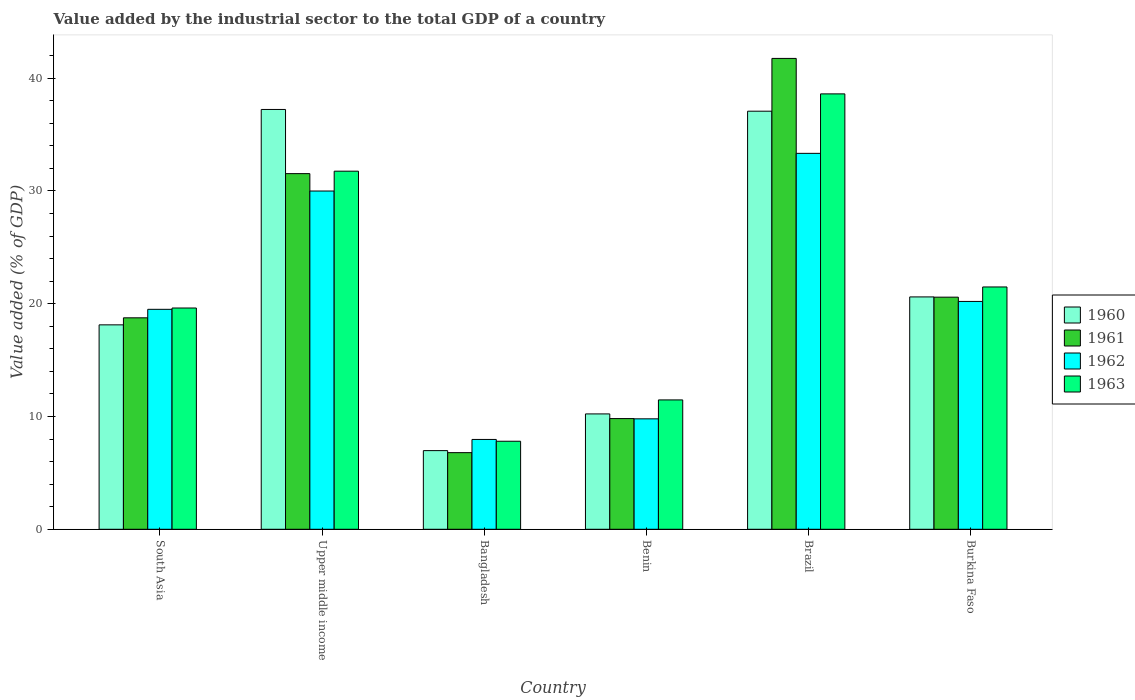How many different coloured bars are there?
Provide a short and direct response. 4. Are the number of bars per tick equal to the number of legend labels?
Keep it short and to the point. Yes. In how many cases, is the number of bars for a given country not equal to the number of legend labels?
Make the answer very short. 0. What is the value added by the industrial sector to the total GDP in 1963 in Bangladesh?
Make the answer very short. 7.8. Across all countries, what is the maximum value added by the industrial sector to the total GDP in 1963?
Keep it short and to the point. 38.6. Across all countries, what is the minimum value added by the industrial sector to the total GDP in 1961?
Give a very brief answer. 6.79. In which country was the value added by the industrial sector to the total GDP in 1960 maximum?
Offer a very short reply. Upper middle income. In which country was the value added by the industrial sector to the total GDP in 1962 minimum?
Your response must be concise. Bangladesh. What is the total value added by the industrial sector to the total GDP in 1961 in the graph?
Offer a very short reply. 129.21. What is the difference between the value added by the industrial sector to the total GDP in 1962 in Bangladesh and that in Upper middle income?
Keep it short and to the point. -22.02. What is the difference between the value added by the industrial sector to the total GDP in 1961 in Bangladesh and the value added by the industrial sector to the total GDP in 1963 in Burkina Faso?
Provide a short and direct response. -14.69. What is the average value added by the industrial sector to the total GDP in 1962 per country?
Offer a very short reply. 20.13. What is the difference between the value added by the industrial sector to the total GDP of/in 1961 and value added by the industrial sector to the total GDP of/in 1963 in Benin?
Ensure brevity in your answer.  -1.66. What is the ratio of the value added by the industrial sector to the total GDP in 1960 in Bangladesh to that in South Asia?
Provide a succinct answer. 0.38. What is the difference between the highest and the second highest value added by the industrial sector to the total GDP in 1963?
Provide a succinct answer. -17.12. What is the difference between the highest and the lowest value added by the industrial sector to the total GDP in 1961?
Make the answer very short. 34.95. Is the sum of the value added by the industrial sector to the total GDP in 1961 in Benin and Upper middle income greater than the maximum value added by the industrial sector to the total GDP in 1962 across all countries?
Your response must be concise. Yes. What does the 1st bar from the left in Burkina Faso represents?
Give a very brief answer. 1960. What does the 1st bar from the right in Benin represents?
Your response must be concise. 1963. Is it the case that in every country, the sum of the value added by the industrial sector to the total GDP in 1962 and value added by the industrial sector to the total GDP in 1960 is greater than the value added by the industrial sector to the total GDP in 1963?
Your answer should be very brief. Yes. Are all the bars in the graph horizontal?
Make the answer very short. No. What is the difference between two consecutive major ticks on the Y-axis?
Your answer should be very brief. 10. Are the values on the major ticks of Y-axis written in scientific E-notation?
Offer a very short reply. No. Does the graph contain grids?
Offer a very short reply. No. Where does the legend appear in the graph?
Keep it short and to the point. Center right. What is the title of the graph?
Your response must be concise. Value added by the industrial sector to the total GDP of a country. What is the label or title of the Y-axis?
Make the answer very short. Value added (% of GDP). What is the Value added (% of GDP) of 1960 in South Asia?
Keep it short and to the point. 18.12. What is the Value added (% of GDP) in 1961 in South Asia?
Keep it short and to the point. 18.75. What is the Value added (% of GDP) of 1962 in South Asia?
Offer a terse response. 19.5. What is the Value added (% of GDP) in 1963 in South Asia?
Provide a succinct answer. 19.62. What is the Value added (% of GDP) of 1960 in Upper middle income?
Provide a succinct answer. 37.22. What is the Value added (% of GDP) in 1961 in Upper middle income?
Your response must be concise. 31.53. What is the Value added (% of GDP) in 1962 in Upper middle income?
Your response must be concise. 29.99. What is the Value added (% of GDP) of 1963 in Upper middle income?
Your answer should be very brief. 31.75. What is the Value added (% of GDP) in 1960 in Bangladesh?
Offer a very short reply. 6.97. What is the Value added (% of GDP) in 1961 in Bangladesh?
Offer a very short reply. 6.79. What is the Value added (% of GDP) in 1962 in Bangladesh?
Make the answer very short. 7.96. What is the Value added (% of GDP) of 1963 in Bangladesh?
Provide a succinct answer. 7.8. What is the Value added (% of GDP) in 1960 in Benin?
Your answer should be very brief. 10.23. What is the Value added (% of GDP) in 1961 in Benin?
Your response must be concise. 9.81. What is the Value added (% of GDP) in 1962 in Benin?
Offer a terse response. 9.79. What is the Value added (% of GDP) of 1963 in Benin?
Ensure brevity in your answer.  11.47. What is the Value added (% of GDP) of 1960 in Brazil?
Your answer should be very brief. 37.07. What is the Value added (% of GDP) of 1961 in Brazil?
Offer a very short reply. 41.75. What is the Value added (% of GDP) of 1962 in Brazil?
Offer a very short reply. 33.33. What is the Value added (% of GDP) in 1963 in Brazil?
Offer a terse response. 38.6. What is the Value added (% of GDP) of 1960 in Burkina Faso?
Provide a short and direct response. 20.6. What is the Value added (% of GDP) in 1961 in Burkina Faso?
Your answer should be very brief. 20.58. What is the Value added (% of GDP) of 1962 in Burkina Faso?
Provide a succinct answer. 20.2. What is the Value added (% of GDP) of 1963 in Burkina Faso?
Your answer should be very brief. 21.48. Across all countries, what is the maximum Value added (% of GDP) of 1960?
Your answer should be compact. 37.22. Across all countries, what is the maximum Value added (% of GDP) of 1961?
Your response must be concise. 41.75. Across all countries, what is the maximum Value added (% of GDP) of 1962?
Your answer should be compact. 33.33. Across all countries, what is the maximum Value added (% of GDP) in 1963?
Offer a terse response. 38.6. Across all countries, what is the minimum Value added (% of GDP) in 1960?
Offer a terse response. 6.97. Across all countries, what is the minimum Value added (% of GDP) of 1961?
Your answer should be very brief. 6.79. Across all countries, what is the minimum Value added (% of GDP) in 1962?
Provide a succinct answer. 7.96. Across all countries, what is the minimum Value added (% of GDP) of 1963?
Your response must be concise. 7.8. What is the total Value added (% of GDP) in 1960 in the graph?
Ensure brevity in your answer.  130.21. What is the total Value added (% of GDP) in 1961 in the graph?
Keep it short and to the point. 129.21. What is the total Value added (% of GDP) in 1962 in the graph?
Offer a terse response. 120.77. What is the total Value added (% of GDP) in 1963 in the graph?
Offer a very short reply. 130.73. What is the difference between the Value added (% of GDP) of 1960 in South Asia and that in Upper middle income?
Give a very brief answer. -19.1. What is the difference between the Value added (% of GDP) of 1961 in South Asia and that in Upper middle income?
Provide a succinct answer. -12.78. What is the difference between the Value added (% of GDP) of 1962 in South Asia and that in Upper middle income?
Your answer should be very brief. -10.49. What is the difference between the Value added (% of GDP) of 1963 in South Asia and that in Upper middle income?
Ensure brevity in your answer.  -12.13. What is the difference between the Value added (% of GDP) of 1960 in South Asia and that in Bangladesh?
Ensure brevity in your answer.  11.15. What is the difference between the Value added (% of GDP) of 1961 in South Asia and that in Bangladesh?
Provide a short and direct response. 11.95. What is the difference between the Value added (% of GDP) of 1962 in South Asia and that in Bangladesh?
Give a very brief answer. 11.54. What is the difference between the Value added (% of GDP) in 1963 in South Asia and that in Bangladesh?
Offer a very short reply. 11.81. What is the difference between the Value added (% of GDP) of 1960 in South Asia and that in Benin?
Provide a succinct answer. 7.9. What is the difference between the Value added (% of GDP) of 1961 in South Asia and that in Benin?
Give a very brief answer. 8.93. What is the difference between the Value added (% of GDP) in 1962 in South Asia and that in Benin?
Make the answer very short. 9.71. What is the difference between the Value added (% of GDP) in 1963 in South Asia and that in Benin?
Offer a terse response. 8.15. What is the difference between the Value added (% of GDP) of 1960 in South Asia and that in Brazil?
Your response must be concise. -18.94. What is the difference between the Value added (% of GDP) of 1961 in South Asia and that in Brazil?
Give a very brief answer. -23. What is the difference between the Value added (% of GDP) in 1962 in South Asia and that in Brazil?
Make the answer very short. -13.83. What is the difference between the Value added (% of GDP) of 1963 in South Asia and that in Brazil?
Offer a very short reply. -18.98. What is the difference between the Value added (% of GDP) in 1960 in South Asia and that in Burkina Faso?
Keep it short and to the point. -2.48. What is the difference between the Value added (% of GDP) of 1961 in South Asia and that in Burkina Faso?
Give a very brief answer. -1.83. What is the difference between the Value added (% of GDP) of 1962 in South Asia and that in Burkina Faso?
Your answer should be compact. -0.7. What is the difference between the Value added (% of GDP) in 1963 in South Asia and that in Burkina Faso?
Offer a terse response. -1.87. What is the difference between the Value added (% of GDP) of 1960 in Upper middle income and that in Bangladesh?
Your answer should be very brief. 30.25. What is the difference between the Value added (% of GDP) of 1961 in Upper middle income and that in Bangladesh?
Your response must be concise. 24.74. What is the difference between the Value added (% of GDP) in 1962 in Upper middle income and that in Bangladesh?
Your response must be concise. 22.02. What is the difference between the Value added (% of GDP) of 1963 in Upper middle income and that in Bangladesh?
Keep it short and to the point. 23.94. What is the difference between the Value added (% of GDP) of 1960 in Upper middle income and that in Benin?
Offer a very short reply. 26.99. What is the difference between the Value added (% of GDP) in 1961 in Upper middle income and that in Benin?
Provide a short and direct response. 21.72. What is the difference between the Value added (% of GDP) of 1962 in Upper middle income and that in Benin?
Your response must be concise. 20.2. What is the difference between the Value added (% of GDP) in 1963 in Upper middle income and that in Benin?
Your answer should be very brief. 20.28. What is the difference between the Value added (% of GDP) in 1960 in Upper middle income and that in Brazil?
Offer a very short reply. 0.15. What is the difference between the Value added (% of GDP) of 1961 in Upper middle income and that in Brazil?
Keep it short and to the point. -10.21. What is the difference between the Value added (% of GDP) of 1962 in Upper middle income and that in Brazil?
Ensure brevity in your answer.  -3.34. What is the difference between the Value added (% of GDP) in 1963 in Upper middle income and that in Brazil?
Keep it short and to the point. -6.85. What is the difference between the Value added (% of GDP) in 1960 in Upper middle income and that in Burkina Faso?
Provide a short and direct response. 16.62. What is the difference between the Value added (% of GDP) of 1961 in Upper middle income and that in Burkina Faso?
Give a very brief answer. 10.95. What is the difference between the Value added (% of GDP) of 1962 in Upper middle income and that in Burkina Faso?
Provide a succinct answer. 9.79. What is the difference between the Value added (% of GDP) of 1963 in Upper middle income and that in Burkina Faso?
Your response must be concise. 10.27. What is the difference between the Value added (% of GDP) in 1960 in Bangladesh and that in Benin?
Offer a very short reply. -3.25. What is the difference between the Value added (% of GDP) of 1961 in Bangladesh and that in Benin?
Your answer should be very brief. -3.02. What is the difference between the Value added (% of GDP) in 1962 in Bangladesh and that in Benin?
Your response must be concise. -1.83. What is the difference between the Value added (% of GDP) in 1963 in Bangladesh and that in Benin?
Provide a succinct answer. -3.66. What is the difference between the Value added (% of GDP) of 1960 in Bangladesh and that in Brazil?
Offer a terse response. -30.09. What is the difference between the Value added (% of GDP) in 1961 in Bangladesh and that in Brazil?
Provide a succinct answer. -34.95. What is the difference between the Value added (% of GDP) in 1962 in Bangladesh and that in Brazil?
Offer a very short reply. -25.37. What is the difference between the Value added (% of GDP) of 1963 in Bangladesh and that in Brazil?
Provide a short and direct response. -30.8. What is the difference between the Value added (% of GDP) of 1960 in Bangladesh and that in Burkina Faso?
Your response must be concise. -13.63. What is the difference between the Value added (% of GDP) of 1961 in Bangladesh and that in Burkina Faso?
Your response must be concise. -13.78. What is the difference between the Value added (% of GDP) of 1962 in Bangladesh and that in Burkina Faso?
Offer a terse response. -12.24. What is the difference between the Value added (% of GDP) in 1963 in Bangladesh and that in Burkina Faso?
Your answer should be very brief. -13.68. What is the difference between the Value added (% of GDP) of 1960 in Benin and that in Brazil?
Make the answer very short. -26.84. What is the difference between the Value added (% of GDP) in 1961 in Benin and that in Brazil?
Your response must be concise. -31.93. What is the difference between the Value added (% of GDP) in 1962 in Benin and that in Brazil?
Make the answer very short. -23.54. What is the difference between the Value added (% of GDP) of 1963 in Benin and that in Brazil?
Your answer should be compact. -27.13. What is the difference between the Value added (% of GDP) in 1960 in Benin and that in Burkina Faso?
Offer a terse response. -10.37. What is the difference between the Value added (% of GDP) of 1961 in Benin and that in Burkina Faso?
Your answer should be compact. -10.76. What is the difference between the Value added (% of GDP) in 1962 in Benin and that in Burkina Faso?
Ensure brevity in your answer.  -10.41. What is the difference between the Value added (% of GDP) in 1963 in Benin and that in Burkina Faso?
Provide a succinct answer. -10.01. What is the difference between the Value added (% of GDP) in 1960 in Brazil and that in Burkina Faso?
Give a very brief answer. 16.47. What is the difference between the Value added (% of GDP) of 1961 in Brazil and that in Burkina Faso?
Provide a succinct answer. 21.17. What is the difference between the Value added (% of GDP) of 1962 in Brazil and that in Burkina Faso?
Ensure brevity in your answer.  13.13. What is the difference between the Value added (% of GDP) of 1963 in Brazil and that in Burkina Faso?
Give a very brief answer. 17.12. What is the difference between the Value added (% of GDP) of 1960 in South Asia and the Value added (% of GDP) of 1961 in Upper middle income?
Your answer should be compact. -13.41. What is the difference between the Value added (% of GDP) in 1960 in South Asia and the Value added (% of GDP) in 1962 in Upper middle income?
Offer a very short reply. -11.86. What is the difference between the Value added (% of GDP) in 1960 in South Asia and the Value added (% of GDP) in 1963 in Upper middle income?
Your response must be concise. -13.63. What is the difference between the Value added (% of GDP) of 1961 in South Asia and the Value added (% of GDP) of 1962 in Upper middle income?
Give a very brief answer. -11.24. What is the difference between the Value added (% of GDP) in 1961 in South Asia and the Value added (% of GDP) in 1963 in Upper middle income?
Offer a very short reply. -13. What is the difference between the Value added (% of GDP) in 1962 in South Asia and the Value added (% of GDP) in 1963 in Upper middle income?
Make the answer very short. -12.25. What is the difference between the Value added (% of GDP) of 1960 in South Asia and the Value added (% of GDP) of 1961 in Bangladesh?
Offer a terse response. 11.33. What is the difference between the Value added (% of GDP) in 1960 in South Asia and the Value added (% of GDP) in 1962 in Bangladesh?
Give a very brief answer. 10.16. What is the difference between the Value added (% of GDP) of 1960 in South Asia and the Value added (% of GDP) of 1963 in Bangladesh?
Offer a terse response. 10.32. What is the difference between the Value added (% of GDP) of 1961 in South Asia and the Value added (% of GDP) of 1962 in Bangladesh?
Make the answer very short. 10.78. What is the difference between the Value added (% of GDP) in 1961 in South Asia and the Value added (% of GDP) in 1963 in Bangladesh?
Offer a very short reply. 10.94. What is the difference between the Value added (% of GDP) of 1962 in South Asia and the Value added (% of GDP) of 1963 in Bangladesh?
Your response must be concise. 11.7. What is the difference between the Value added (% of GDP) in 1960 in South Asia and the Value added (% of GDP) in 1961 in Benin?
Provide a succinct answer. 8.31. What is the difference between the Value added (% of GDP) of 1960 in South Asia and the Value added (% of GDP) of 1962 in Benin?
Keep it short and to the point. 8.33. What is the difference between the Value added (% of GDP) in 1960 in South Asia and the Value added (% of GDP) in 1963 in Benin?
Your answer should be compact. 6.65. What is the difference between the Value added (% of GDP) of 1961 in South Asia and the Value added (% of GDP) of 1962 in Benin?
Give a very brief answer. 8.96. What is the difference between the Value added (% of GDP) in 1961 in South Asia and the Value added (% of GDP) in 1963 in Benin?
Your response must be concise. 7.28. What is the difference between the Value added (% of GDP) in 1962 in South Asia and the Value added (% of GDP) in 1963 in Benin?
Keep it short and to the point. 8.03. What is the difference between the Value added (% of GDP) in 1960 in South Asia and the Value added (% of GDP) in 1961 in Brazil?
Your answer should be very brief. -23.62. What is the difference between the Value added (% of GDP) of 1960 in South Asia and the Value added (% of GDP) of 1962 in Brazil?
Offer a terse response. -15.21. What is the difference between the Value added (% of GDP) of 1960 in South Asia and the Value added (% of GDP) of 1963 in Brazil?
Your answer should be compact. -20.48. What is the difference between the Value added (% of GDP) of 1961 in South Asia and the Value added (% of GDP) of 1962 in Brazil?
Offer a terse response. -14.58. What is the difference between the Value added (% of GDP) in 1961 in South Asia and the Value added (% of GDP) in 1963 in Brazil?
Your answer should be compact. -19.85. What is the difference between the Value added (% of GDP) in 1962 in South Asia and the Value added (% of GDP) in 1963 in Brazil?
Your response must be concise. -19.1. What is the difference between the Value added (% of GDP) in 1960 in South Asia and the Value added (% of GDP) in 1961 in Burkina Faso?
Offer a very short reply. -2.45. What is the difference between the Value added (% of GDP) of 1960 in South Asia and the Value added (% of GDP) of 1962 in Burkina Faso?
Give a very brief answer. -2.08. What is the difference between the Value added (% of GDP) of 1960 in South Asia and the Value added (% of GDP) of 1963 in Burkina Faso?
Provide a succinct answer. -3.36. What is the difference between the Value added (% of GDP) of 1961 in South Asia and the Value added (% of GDP) of 1962 in Burkina Faso?
Keep it short and to the point. -1.45. What is the difference between the Value added (% of GDP) in 1961 in South Asia and the Value added (% of GDP) in 1963 in Burkina Faso?
Offer a very short reply. -2.74. What is the difference between the Value added (% of GDP) of 1962 in South Asia and the Value added (% of GDP) of 1963 in Burkina Faso?
Offer a terse response. -1.98. What is the difference between the Value added (% of GDP) in 1960 in Upper middle income and the Value added (% of GDP) in 1961 in Bangladesh?
Provide a succinct answer. 30.43. What is the difference between the Value added (% of GDP) of 1960 in Upper middle income and the Value added (% of GDP) of 1962 in Bangladesh?
Provide a succinct answer. 29.26. What is the difference between the Value added (% of GDP) of 1960 in Upper middle income and the Value added (% of GDP) of 1963 in Bangladesh?
Your answer should be compact. 29.42. What is the difference between the Value added (% of GDP) of 1961 in Upper middle income and the Value added (% of GDP) of 1962 in Bangladesh?
Offer a very short reply. 23.57. What is the difference between the Value added (% of GDP) in 1961 in Upper middle income and the Value added (% of GDP) in 1963 in Bangladesh?
Offer a very short reply. 23.73. What is the difference between the Value added (% of GDP) of 1962 in Upper middle income and the Value added (% of GDP) of 1963 in Bangladesh?
Provide a succinct answer. 22.18. What is the difference between the Value added (% of GDP) in 1960 in Upper middle income and the Value added (% of GDP) in 1961 in Benin?
Provide a succinct answer. 27.41. What is the difference between the Value added (% of GDP) of 1960 in Upper middle income and the Value added (% of GDP) of 1962 in Benin?
Provide a short and direct response. 27.43. What is the difference between the Value added (% of GDP) in 1960 in Upper middle income and the Value added (% of GDP) in 1963 in Benin?
Offer a terse response. 25.75. What is the difference between the Value added (% of GDP) of 1961 in Upper middle income and the Value added (% of GDP) of 1962 in Benin?
Give a very brief answer. 21.74. What is the difference between the Value added (% of GDP) of 1961 in Upper middle income and the Value added (% of GDP) of 1963 in Benin?
Your response must be concise. 20.06. What is the difference between the Value added (% of GDP) in 1962 in Upper middle income and the Value added (% of GDP) in 1963 in Benin?
Your answer should be very brief. 18.52. What is the difference between the Value added (% of GDP) of 1960 in Upper middle income and the Value added (% of GDP) of 1961 in Brazil?
Offer a terse response. -4.53. What is the difference between the Value added (% of GDP) in 1960 in Upper middle income and the Value added (% of GDP) in 1962 in Brazil?
Provide a succinct answer. 3.89. What is the difference between the Value added (% of GDP) of 1960 in Upper middle income and the Value added (% of GDP) of 1963 in Brazil?
Provide a short and direct response. -1.38. What is the difference between the Value added (% of GDP) of 1961 in Upper middle income and the Value added (% of GDP) of 1962 in Brazil?
Offer a terse response. -1.8. What is the difference between the Value added (% of GDP) of 1961 in Upper middle income and the Value added (% of GDP) of 1963 in Brazil?
Provide a short and direct response. -7.07. What is the difference between the Value added (% of GDP) in 1962 in Upper middle income and the Value added (% of GDP) in 1963 in Brazil?
Offer a very short reply. -8.61. What is the difference between the Value added (% of GDP) of 1960 in Upper middle income and the Value added (% of GDP) of 1961 in Burkina Faso?
Offer a very short reply. 16.64. What is the difference between the Value added (% of GDP) in 1960 in Upper middle income and the Value added (% of GDP) in 1962 in Burkina Faso?
Provide a short and direct response. 17.02. What is the difference between the Value added (% of GDP) of 1960 in Upper middle income and the Value added (% of GDP) of 1963 in Burkina Faso?
Provide a short and direct response. 15.74. What is the difference between the Value added (% of GDP) in 1961 in Upper middle income and the Value added (% of GDP) in 1962 in Burkina Faso?
Make the answer very short. 11.33. What is the difference between the Value added (% of GDP) in 1961 in Upper middle income and the Value added (% of GDP) in 1963 in Burkina Faso?
Give a very brief answer. 10.05. What is the difference between the Value added (% of GDP) in 1962 in Upper middle income and the Value added (% of GDP) in 1963 in Burkina Faso?
Keep it short and to the point. 8.5. What is the difference between the Value added (% of GDP) of 1960 in Bangladesh and the Value added (% of GDP) of 1961 in Benin?
Provide a succinct answer. -2.84. What is the difference between the Value added (% of GDP) in 1960 in Bangladesh and the Value added (% of GDP) in 1962 in Benin?
Your answer should be very brief. -2.82. What is the difference between the Value added (% of GDP) of 1960 in Bangladesh and the Value added (% of GDP) of 1963 in Benin?
Ensure brevity in your answer.  -4.5. What is the difference between the Value added (% of GDP) of 1961 in Bangladesh and the Value added (% of GDP) of 1962 in Benin?
Your answer should be very brief. -3. What is the difference between the Value added (% of GDP) in 1961 in Bangladesh and the Value added (% of GDP) in 1963 in Benin?
Your answer should be compact. -4.68. What is the difference between the Value added (% of GDP) of 1962 in Bangladesh and the Value added (% of GDP) of 1963 in Benin?
Provide a short and direct response. -3.51. What is the difference between the Value added (% of GDP) in 1960 in Bangladesh and the Value added (% of GDP) in 1961 in Brazil?
Ensure brevity in your answer.  -34.77. What is the difference between the Value added (% of GDP) of 1960 in Bangladesh and the Value added (% of GDP) of 1962 in Brazil?
Your answer should be very brief. -26.36. What is the difference between the Value added (% of GDP) in 1960 in Bangladesh and the Value added (% of GDP) in 1963 in Brazil?
Your answer should be very brief. -31.63. What is the difference between the Value added (% of GDP) of 1961 in Bangladesh and the Value added (% of GDP) of 1962 in Brazil?
Give a very brief answer. -26.53. What is the difference between the Value added (% of GDP) in 1961 in Bangladesh and the Value added (% of GDP) in 1963 in Brazil?
Offer a terse response. -31.81. What is the difference between the Value added (% of GDP) of 1962 in Bangladesh and the Value added (% of GDP) of 1963 in Brazil?
Make the answer very short. -30.64. What is the difference between the Value added (% of GDP) in 1960 in Bangladesh and the Value added (% of GDP) in 1961 in Burkina Faso?
Make the answer very short. -13.6. What is the difference between the Value added (% of GDP) in 1960 in Bangladesh and the Value added (% of GDP) in 1962 in Burkina Faso?
Offer a terse response. -13.23. What is the difference between the Value added (% of GDP) in 1960 in Bangladesh and the Value added (% of GDP) in 1963 in Burkina Faso?
Keep it short and to the point. -14.51. What is the difference between the Value added (% of GDP) of 1961 in Bangladesh and the Value added (% of GDP) of 1962 in Burkina Faso?
Make the answer very short. -13.41. What is the difference between the Value added (% of GDP) of 1961 in Bangladesh and the Value added (% of GDP) of 1963 in Burkina Faso?
Your response must be concise. -14.69. What is the difference between the Value added (% of GDP) of 1962 in Bangladesh and the Value added (% of GDP) of 1963 in Burkina Faso?
Make the answer very short. -13.52. What is the difference between the Value added (% of GDP) of 1960 in Benin and the Value added (% of GDP) of 1961 in Brazil?
Ensure brevity in your answer.  -31.52. What is the difference between the Value added (% of GDP) of 1960 in Benin and the Value added (% of GDP) of 1962 in Brazil?
Your answer should be compact. -23.1. What is the difference between the Value added (% of GDP) of 1960 in Benin and the Value added (% of GDP) of 1963 in Brazil?
Give a very brief answer. -28.37. What is the difference between the Value added (% of GDP) of 1961 in Benin and the Value added (% of GDP) of 1962 in Brazil?
Provide a short and direct response. -23.52. What is the difference between the Value added (% of GDP) in 1961 in Benin and the Value added (% of GDP) in 1963 in Brazil?
Provide a short and direct response. -28.79. What is the difference between the Value added (% of GDP) in 1962 in Benin and the Value added (% of GDP) in 1963 in Brazil?
Offer a terse response. -28.81. What is the difference between the Value added (% of GDP) of 1960 in Benin and the Value added (% of GDP) of 1961 in Burkina Faso?
Ensure brevity in your answer.  -10.35. What is the difference between the Value added (% of GDP) in 1960 in Benin and the Value added (% of GDP) in 1962 in Burkina Faso?
Give a very brief answer. -9.97. What is the difference between the Value added (% of GDP) of 1960 in Benin and the Value added (% of GDP) of 1963 in Burkina Faso?
Provide a succinct answer. -11.26. What is the difference between the Value added (% of GDP) in 1961 in Benin and the Value added (% of GDP) in 1962 in Burkina Faso?
Provide a short and direct response. -10.39. What is the difference between the Value added (% of GDP) in 1961 in Benin and the Value added (% of GDP) in 1963 in Burkina Faso?
Offer a very short reply. -11.67. What is the difference between the Value added (% of GDP) in 1962 in Benin and the Value added (% of GDP) in 1963 in Burkina Faso?
Your answer should be very brief. -11.69. What is the difference between the Value added (% of GDP) in 1960 in Brazil and the Value added (% of GDP) in 1961 in Burkina Faso?
Your answer should be compact. 16.49. What is the difference between the Value added (% of GDP) in 1960 in Brazil and the Value added (% of GDP) in 1962 in Burkina Faso?
Keep it short and to the point. 16.87. What is the difference between the Value added (% of GDP) of 1960 in Brazil and the Value added (% of GDP) of 1963 in Burkina Faso?
Make the answer very short. 15.58. What is the difference between the Value added (% of GDP) in 1961 in Brazil and the Value added (% of GDP) in 1962 in Burkina Faso?
Make the answer very short. 21.54. What is the difference between the Value added (% of GDP) in 1961 in Brazil and the Value added (% of GDP) in 1963 in Burkina Faso?
Provide a succinct answer. 20.26. What is the difference between the Value added (% of GDP) in 1962 in Brazil and the Value added (% of GDP) in 1963 in Burkina Faso?
Your answer should be very brief. 11.85. What is the average Value added (% of GDP) in 1960 per country?
Offer a terse response. 21.7. What is the average Value added (% of GDP) in 1961 per country?
Offer a very short reply. 21.53. What is the average Value added (% of GDP) of 1962 per country?
Keep it short and to the point. 20.13. What is the average Value added (% of GDP) in 1963 per country?
Your answer should be very brief. 21.79. What is the difference between the Value added (% of GDP) in 1960 and Value added (% of GDP) in 1961 in South Asia?
Your response must be concise. -0.62. What is the difference between the Value added (% of GDP) of 1960 and Value added (% of GDP) of 1962 in South Asia?
Provide a succinct answer. -1.38. What is the difference between the Value added (% of GDP) of 1960 and Value added (% of GDP) of 1963 in South Asia?
Provide a succinct answer. -1.49. What is the difference between the Value added (% of GDP) of 1961 and Value added (% of GDP) of 1962 in South Asia?
Your response must be concise. -0.75. What is the difference between the Value added (% of GDP) in 1961 and Value added (% of GDP) in 1963 in South Asia?
Your answer should be very brief. -0.87. What is the difference between the Value added (% of GDP) of 1962 and Value added (% of GDP) of 1963 in South Asia?
Give a very brief answer. -0.12. What is the difference between the Value added (% of GDP) of 1960 and Value added (% of GDP) of 1961 in Upper middle income?
Ensure brevity in your answer.  5.69. What is the difference between the Value added (% of GDP) in 1960 and Value added (% of GDP) in 1962 in Upper middle income?
Your answer should be compact. 7.23. What is the difference between the Value added (% of GDP) of 1960 and Value added (% of GDP) of 1963 in Upper middle income?
Offer a terse response. 5.47. What is the difference between the Value added (% of GDP) of 1961 and Value added (% of GDP) of 1962 in Upper middle income?
Provide a succinct answer. 1.54. What is the difference between the Value added (% of GDP) of 1961 and Value added (% of GDP) of 1963 in Upper middle income?
Ensure brevity in your answer.  -0.22. What is the difference between the Value added (% of GDP) in 1962 and Value added (% of GDP) in 1963 in Upper middle income?
Provide a short and direct response. -1.76. What is the difference between the Value added (% of GDP) in 1960 and Value added (% of GDP) in 1961 in Bangladesh?
Keep it short and to the point. 0.18. What is the difference between the Value added (% of GDP) of 1960 and Value added (% of GDP) of 1962 in Bangladesh?
Give a very brief answer. -0.99. What is the difference between the Value added (% of GDP) of 1960 and Value added (% of GDP) of 1963 in Bangladesh?
Offer a very short reply. -0.83. What is the difference between the Value added (% of GDP) in 1961 and Value added (% of GDP) in 1962 in Bangladesh?
Your response must be concise. -1.17. What is the difference between the Value added (% of GDP) of 1961 and Value added (% of GDP) of 1963 in Bangladesh?
Your answer should be very brief. -1.01. What is the difference between the Value added (% of GDP) of 1962 and Value added (% of GDP) of 1963 in Bangladesh?
Ensure brevity in your answer.  0.16. What is the difference between the Value added (% of GDP) of 1960 and Value added (% of GDP) of 1961 in Benin?
Provide a succinct answer. 0.41. What is the difference between the Value added (% of GDP) of 1960 and Value added (% of GDP) of 1962 in Benin?
Offer a very short reply. 0.44. What is the difference between the Value added (% of GDP) in 1960 and Value added (% of GDP) in 1963 in Benin?
Give a very brief answer. -1.24. What is the difference between the Value added (% of GDP) of 1961 and Value added (% of GDP) of 1962 in Benin?
Your response must be concise. 0.02. What is the difference between the Value added (% of GDP) in 1961 and Value added (% of GDP) in 1963 in Benin?
Ensure brevity in your answer.  -1.66. What is the difference between the Value added (% of GDP) of 1962 and Value added (% of GDP) of 1963 in Benin?
Offer a terse response. -1.68. What is the difference between the Value added (% of GDP) in 1960 and Value added (% of GDP) in 1961 in Brazil?
Offer a terse response. -4.68. What is the difference between the Value added (% of GDP) of 1960 and Value added (% of GDP) of 1962 in Brazil?
Provide a short and direct response. 3.74. What is the difference between the Value added (% of GDP) of 1960 and Value added (% of GDP) of 1963 in Brazil?
Your answer should be very brief. -1.53. What is the difference between the Value added (% of GDP) in 1961 and Value added (% of GDP) in 1962 in Brazil?
Keep it short and to the point. 8.42. What is the difference between the Value added (% of GDP) of 1961 and Value added (% of GDP) of 1963 in Brazil?
Provide a short and direct response. 3.14. What is the difference between the Value added (% of GDP) of 1962 and Value added (% of GDP) of 1963 in Brazil?
Give a very brief answer. -5.27. What is the difference between the Value added (% of GDP) of 1960 and Value added (% of GDP) of 1961 in Burkina Faso?
Your answer should be compact. 0.02. What is the difference between the Value added (% of GDP) of 1960 and Value added (% of GDP) of 1962 in Burkina Faso?
Your response must be concise. 0.4. What is the difference between the Value added (% of GDP) of 1960 and Value added (% of GDP) of 1963 in Burkina Faso?
Your answer should be compact. -0.88. What is the difference between the Value added (% of GDP) in 1961 and Value added (% of GDP) in 1962 in Burkina Faso?
Offer a terse response. 0.38. What is the difference between the Value added (% of GDP) of 1961 and Value added (% of GDP) of 1963 in Burkina Faso?
Provide a succinct answer. -0.91. What is the difference between the Value added (% of GDP) in 1962 and Value added (% of GDP) in 1963 in Burkina Faso?
Provide a succinct answer. -1.28. What is the ratio of the Value added (% of GDP) in 1960 in South Asia to that in Upper middle income?
Provide a succinct answer. 0.49. What is the ratio of the Value added (% of GDP) of 1961 in South Asia to that in Upper middle income?
Keep it short and to the point. 0.59. What is the ratio of the Value added (% of GDP) in 1962 in South Asia to that in Upper middle income?
Give a very brief answer. 0.65. What is the ratio of the Value added (% of GDP) of 1963 in South Asia to that in Upper middle income?
Your response must be concise. 0.62. What is the ratio of the Value added (% of GDP) of 1960 in South Asia to that in Bangladesh?
Keep it short and to the point. 2.6. What is the ratio of the Value added (% of GDP) of 1961 in South Asia to that in Bangladesh?
Provide a succinct answer. 2.76. What is the ratio of the Value added (% of GDP) of 1962 in South Asia to that in Bangladesh?
Offer a terse response. 2.45. What is the ratio of the Value added (% of GDP) of 1963 in South Asia to that in Bangladesh?
Your response must be concise. 2.51. What is the ratio of the Value added (% of GDP) in 1960 in South Asia to that in Benin?
Provide a short and direct response. 1.77. What is the ratio of the Value added (% of GDP) in 1961 in South Asia to that in Benin?
Offer a very short reply. 1.91. What is the ratio of the Value added (% of GDP) of 1962 in South Asia to that in Benin?
Your answer should be compact. 1.99. What is the ratio of the Value added (% of GDP) in 1963 in South Asia to that in Benin?
Offer a very short reply. 1.71. What is the ratio of the Value added (% of GDP) of 1960 in South Asia to that in Brazil?
Your answer should be very brief. 0.49. What is the ratio of the Value added (% of GDP) in 1961 in South Asia to that in Brazil?
Make the answer very short. 0.45. What is the ratio of the Value added (% of GDP) of 1962 in South Asia to that in Brazil?
Give a very brief answer. 0.59. What is the ratio of the Value added (% of GDP) in 1963 in South Asia to that in Brazil?
Offer a very short reply. 0.51. What is the ratio of the Value added (% of GDP) in 1960 in South Asia to that in Burkina Faso?
Ensure brevity in your answer.  0.88. What is the ratio of the Value added (% of GDP) of 1961 in South Asia to that in Burkina Faso?
Ensure brevity in your answer.  0.91. What is the ratio of the Value added (% of GDP) in 1962 in South Asia to that in Burkina Faso?
Your response must be concise. 0.97. What is the ratio of the Value added (% of GDP) in 1963 in South Asia to that in Burkina Faso?
Give a very brief answer. 0.91. What is the ratio of the Value added (% of GDP) of 1960 in Upper middle income to that in Bangladesh?
Your answer should be compact. 5.34. What is the ratio of the Value added (% of GDP) of 1961 in Upper middle income to that in Bangladesh?
Your response must be concise. 4.64. What is the ratio of the Value added (% of GDP) in 1962 in Upper middle income to that in Bangladesh?
Offer a very short reply. 3.77. What is the ratio of the Value added (% of GDP) in 1963 in Upper middle income to that in Bangladesh?
Offer a very short reply. 4.07. What is the ratio of the Value added (% of GDP) of 1960 in Upper middle income to that in Benin?
Provide a short and direct response. 3.64. What is the ratio of the Value added (% of GDP) in 1961 in Upper middle income to that in Benin?
Offer a very short reply. 3.21. What is the ratio of the Value added (% of GDP) of 1962 in Upper middle income to that in Benin?
Your response must be concise. 3.06. What is the ratio of the Value added (% of GDP) in 1963 in Upper middle income to that in Benin?
Your response must be concise. 2.77. What is the ratio of the Value added (% of GDP) of 1960 in Upper middle income to that in Brazil?
Offer a very short reply. 1. What is the ratio of the Value added (% of GDP) in 1961 in Upper middle income to that in Brazil?
Your answer should be very brief. 0.76. What is the ratio of the Value added (% of GDP) of 1962 in Upper middle income to that in Brazil?
Provide a short and direct response. 0.9. What is the ratio of the Value added (% of GDP) of 1963 in Upper middle income to that in Brazil?
Offer a terse response. 0.82. What is the ratio of the Value added (% of GDP) of 1960 in Upper middle income to that in Burkina Faso?
Your response must be concise. 1.81. What is the ratio of the Value added (% of GDP) in 1961 in Upper middle income to that in Burkina Faso?
Make the answer very short. 1.53. What is the ratio of the Value added (% of GDP) in 1962 in Upper middle income to that in Burkina Faso?
Your response must be concise. 1.48. What is the ratio of the Value added (% of GDP) of 1963 in Upper middle income to that in Burkina Faso?
Provide a short and direct response. 1.48. What is the ratio of the Value added (% of GDP) of 1960 in Bangladesh to that in Benin?
Provide a short and direct response. 0.68. What is the ratio of the Value added (% of GDP) of 1961 in Bangladesh to that in Benin?
Ensure brevity in your answer.  0.69. What is the ratio of the Value added (% of GDP) in 1962 in Bangladesh to that in Benin?
Provide a short and direct response. 0.81. What is the ratio of the Value added (% of GDP) in 1963 in Bangladesh to that in Benin?
Your response must be concise. 0.68. What is the ratio of the Value added (% of GDP) of 1960 in Bangladesh to that in Brazil?
Your answer should be compact. 0.19. What is the ratio of the Value added (% of GDP) in 1961 in Bangladesh to that in Brazil?
Offer a very short reply. 0.16. What is the ratio of the Value added (% of GDP) in 1962 in Bangladesh to that in Brazil?
Provide a short and direct response. 0.24. What is the ratio of the Value added (% of GDP) in 1963 in Bangladesh to that in Brazil?
Keep it short and to the point. 0.2. What is the ratio of the Value added (% of GDP) of 1960 in Bangladesh to that in Burkina Faso?
Ensure brevity in your answer.  0.34. What is the ratio of the Value added (% of GDP) in 1961 in Bangladesh to that in Burkina Faso?
Offer a terse response. 0.33. What is the ratio of the Value added (% of GDP) in 1962 in Bangladesh to that in Burkina Faso?
Provide a succinct answer. 0.39. What is the ratio of the Value added (% of GDP) in 1963 in Bangladesh to that in Burkina Faso?
Keep it short and to the point. 0.36. What is the ratio of the Value added (% of GDP) of 1960 in Benin to that in Brazil?
Your response must be concise. 0.28. What is the ratio of the Value added (% of GDP) in 1961 in Benin to that in Brazil?
Offer a very short reply. 0.24. What is the ratio of the Value added (% of GDP) of 1962 in Benin to that in Brazil?
Give a very brief answer. 0.29. What is the ratio of the Value added (% of GDP) of 1963 in Benin to that in Brazil?
Offer a very short reply. 0.3. What is the ratio of the Value added (% of GDP) of 1960 in Benin to that in Burkina Faso?
Ensure brevity in your answer.  0.5. What is the ratio of the Value added (% of GDP) of 1961 in Benin to that in Burkina Faso?
Give a very brief answer. 0.48. What is the ratio of the Value added (% of GDP) in 1962 in Benin to that in Burkina Faso?
Give a very brief answer. 0.48. What is the ratio of the Value added (% of GDP) of 1963 in Benin to that in Burkina Faso?
Your answer should be compact. 0.53. What is the ratio of the Value added (% of GDP) in 1960 in Brazil to that in Burkina Faso?
Your answer should be compact. 1.8. What is the ratio of the Value added (% of GDP) of 1961 in Brazil to that in Burkina Faso?
Make the answer very short. 2.03. What is the ratio of the Value added (% of GDP) of 1962 in Brazil to that in Burkina Faso?
Give a very brief answer. 1.65. What is the ratio of the Value added (% of GDP) in 1963 in Brazil to that in Burkina Faso?
Your answer should be compact. 1.8. What is the difference between the highest and the second highest Value added (% of GDP) in 1960?
Your answer should be very brief. 0.15. What is the difference between the highest and the second highest Value added (% of GDP) of 1961?
Offer a very short reply. 10.21. What is the difference between the highest and the second highest Value added (% of GDP) of 1962?
Make the answer very short. 3.34. What is the difference between the highest and the second highest Value added (% of GDP) in 1963?
Your answer should be very brief. 6.85. What is the difference between the highest and the lowest Value added (% of GDP) in 1960?
Make the answer very short. 30.25. What is the difference between the highest and the lowest Value added (% of GDP) of 1961?
Your answer should be very brief. 34.95. What is the difference between the highest and the lowest Value added (% of GDP) of 1962?
Ensure brevity in your answer.  25.37. What is the difference between the highest and the lowest Value added (% of GDP) of 1963?
Provide a short and direct response. 30.8. 